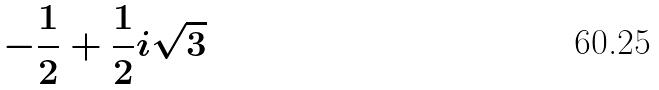Convert formula to latex. <formula><loc_0><loc_0><loc_500><loc_500>- \frac { 1 } { 2 } + \frac { 1 } { 2 } i \sqrt { 3 }</formula> 